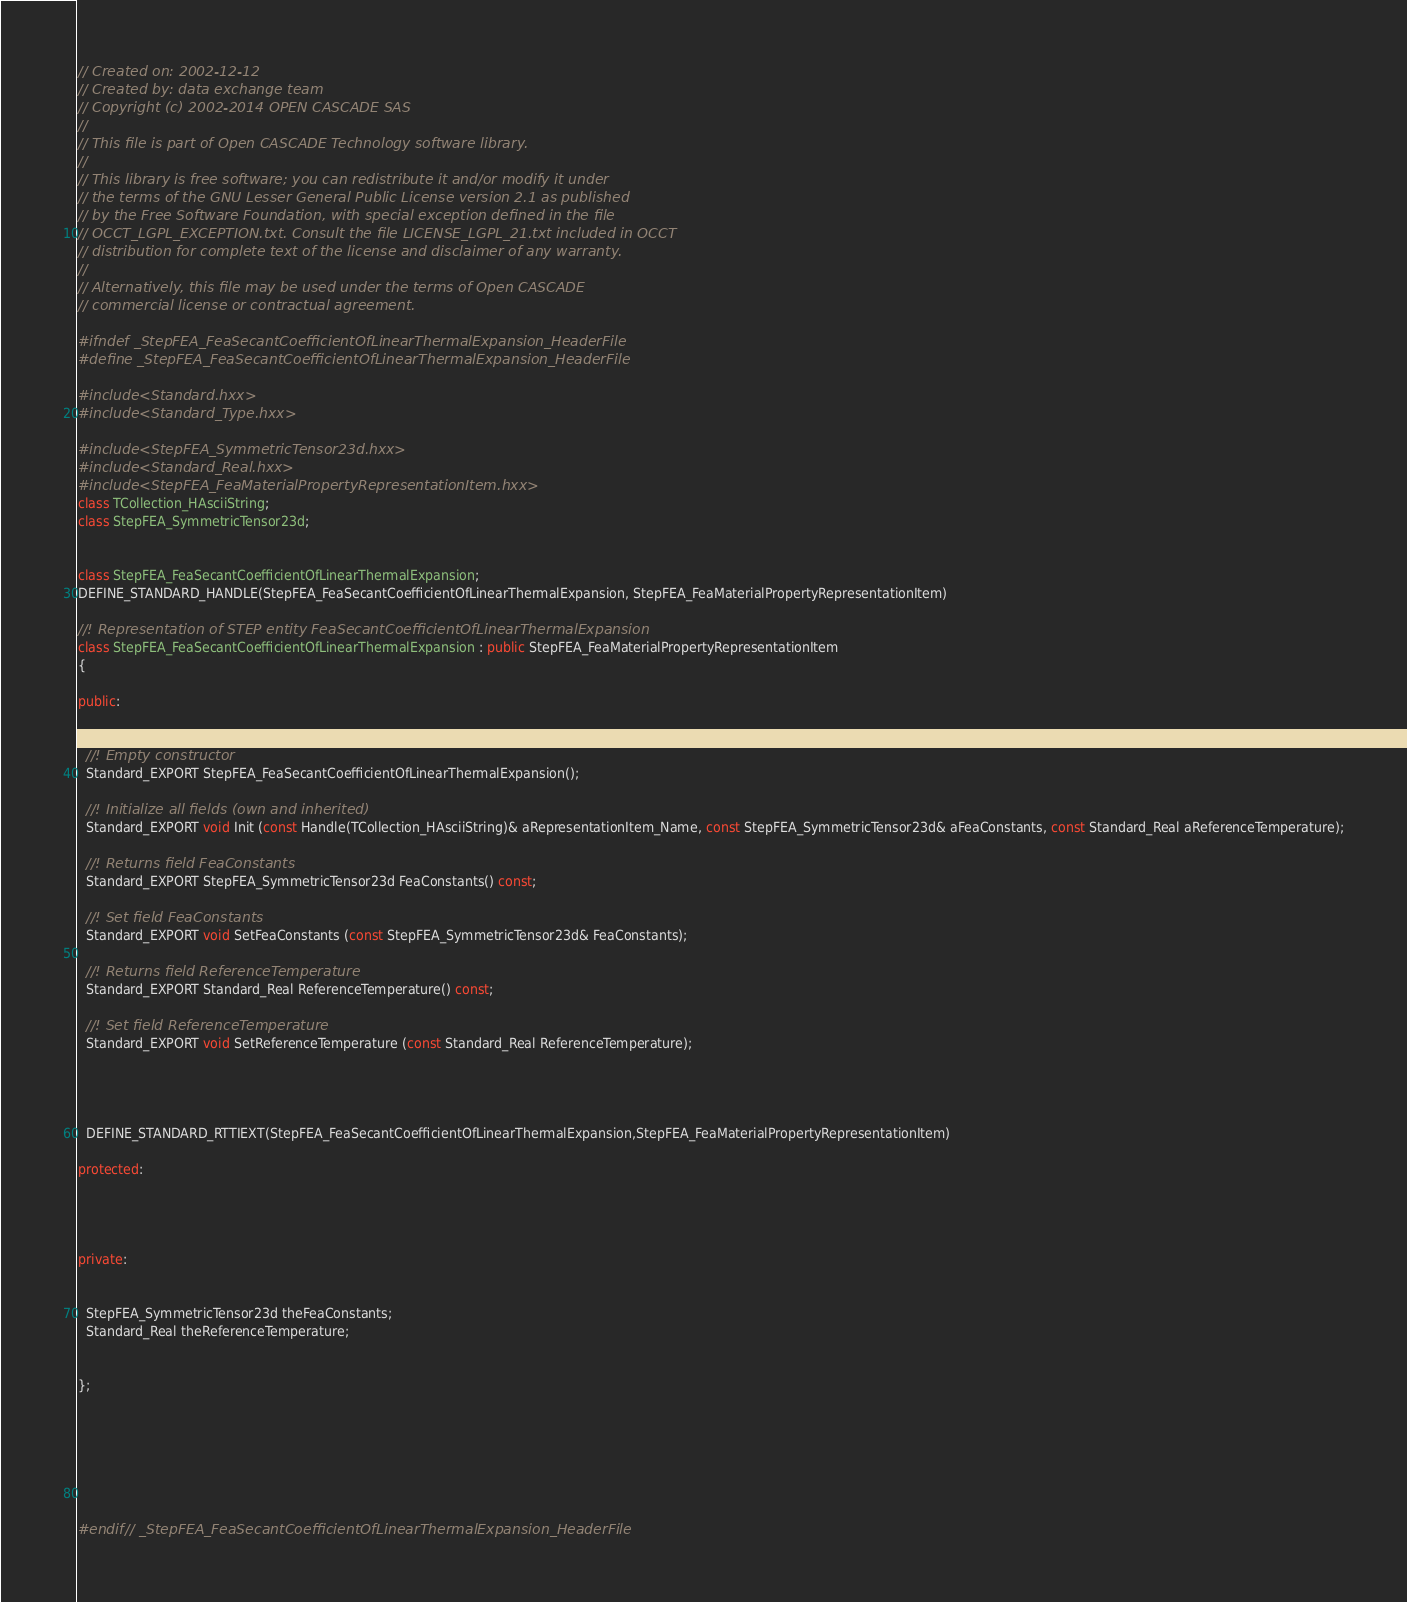Convert code to text. <code><loc_0><loc_0><loc_500><loc_500><_C++_>// Created on: 2002-12-12
// Created by: data exchange team
// Copyright (c) 2002-2014 OPEN CASCADE SAS
//
// This file is part of Open CASCADE Technology software library.
//
// This library is free software; you can redistribute it and/or modify it under
// the terms of the GNU Lesser General Public License version 2.1 as published
// by the Free Software Foundation, with special exception defined in the file
// OCCT_LGPL_EXCEPTION.txt. Consult the file LICENSE_LGPL_21.txt included in OCCT
// distribution for complete text of the license and disclaimer of any warranty.
//
// Alternatively, this file may be used under the terms of Open CASCADE
// commercial license or contractual agreement.

#ifndef _StepFEA_FeaSecantCoefficientOfLinearThermalExpansion_HeaderFile
#define _StepFEA_FeaSecantCoefficientOfLinearThermalExpansion_HeaderFile

#include <Standard.hxx>
#include <Standard_Type.hxx>

#include <StepFEA_SymmetricTensor23d.hxx>
#include <Standard_Real.hxx>
#include <StepFEA_FeaMaterialPropertyRepresentationItem.hxx>
class TCollection_HAsciiString;
class StepFEA_SymmetricTensor23d;


class StepFEA_FeaSecantCoefficientOfLinearThermalExpansion;
DEFINE_STANDARD_HANDLE(StepFEA_FeaSecantCoefficientOfLinearThermalExpansion, StepFEA_FeaMaterialPropertyRepresentationItem)

//! Representation of STEP entity FeaSecantCoefficientOfLinearThermalExpansion
class StepFEA_FeaSecantCoefficientOfLinearThermalExpansion : public StepFEA_FeaMaterialPropertyRepresentationItem
{

public:

  
  //! Empty constructor
  Standard_EXPORT StepFEA_FeaSecantCoefficientOfLinearThermalExpansion();
  
  //! Initialize all fields (own and inherited)
  Standard_EXPORT void Init (const Handle(TCollection_HAsciiString)& aRepresentationItem_Name, const StepFEA_SymmetricTensor23d& aFeaConstants, const Standard_Real aReferenceTemperature);
  
  //! Returns field FeaConstants
  Standard_EXPORT StepFEA_SymmetricTensor23d FeaConstants() const;
  
  //! Set field FeaConstants
  Standard_EXPORT void SetFeaConstants (const StepFEA_SymmetricTensor23d& FeaConstants);
  
  //! Returns field ReferenceTemperature
  Standard_EXPORT Standard_Real ReferenceTemperature() const;
  
  //! Set field ReferenceTemperature
  Standard_EXPORT void SetReferenceTemperature (const Standard_Real ReferenceTemperature);




  DEFINE_STANDARD_RTTIEXT(StepFEA_FeaSecantCoefficientOfLinearThermalExpansion,StepFEA_FeaMaterialPropertyRepresentationItem)

protected:




private:


  StepFEA_SymmetricTensor23d theFeaConstants;
  Standard_Real theReferenceTemperature;


};







#endif // _StepFEA_FeaSecantCoefficientOfLinearThermalExpansion_HeaderFile
</code> 